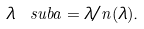Convert formula to latex. <formula><loc_0><loc_0><loc_500><loc_500>\lambda \ s u b { a } = \lambda / n ( \lambda ) .</formula> 